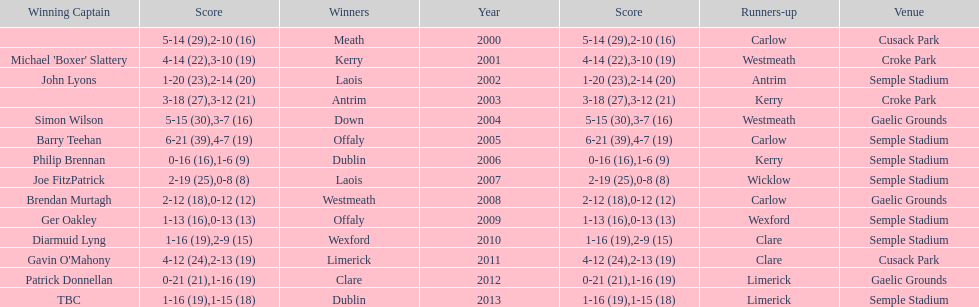What is the total number of times the competition was held at the semple stadium venue? 7. 